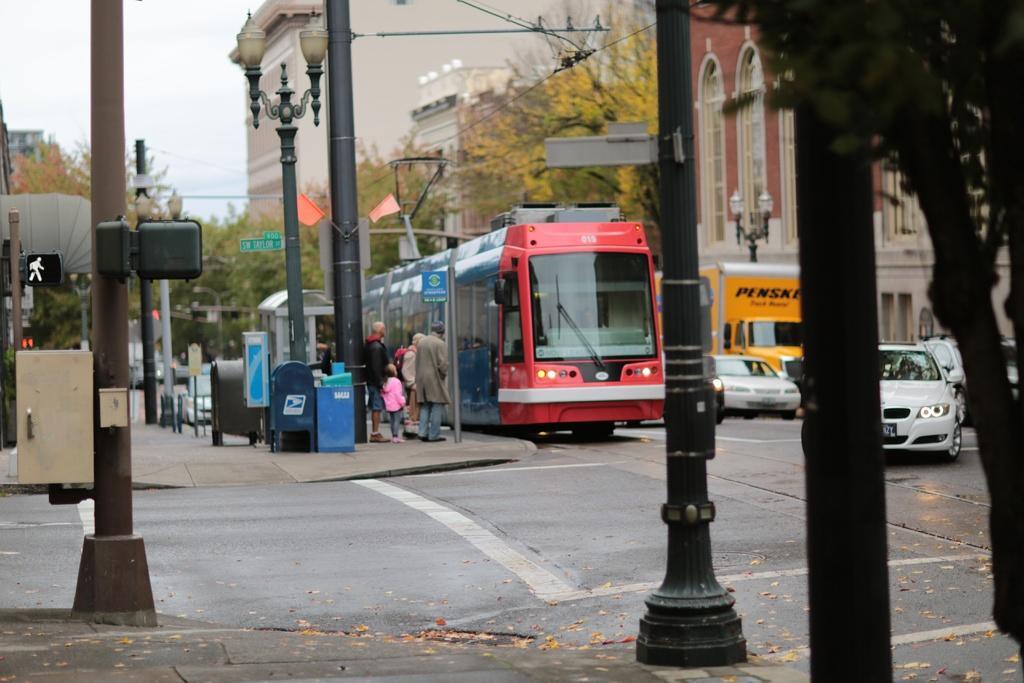In one or two sentences, can you explain what this image depicts? This picture is clicked outside the city. Here, we see cars and the bus are moving on the road. Beside the bus, we see people standing on the footpath. Beside them, we see street lights and garbage bin. On the left side, we see a building and poles. On the right side, we see street lights, buildings and trees. In the left top of the picture, we see the sky and there are trees in the background. 